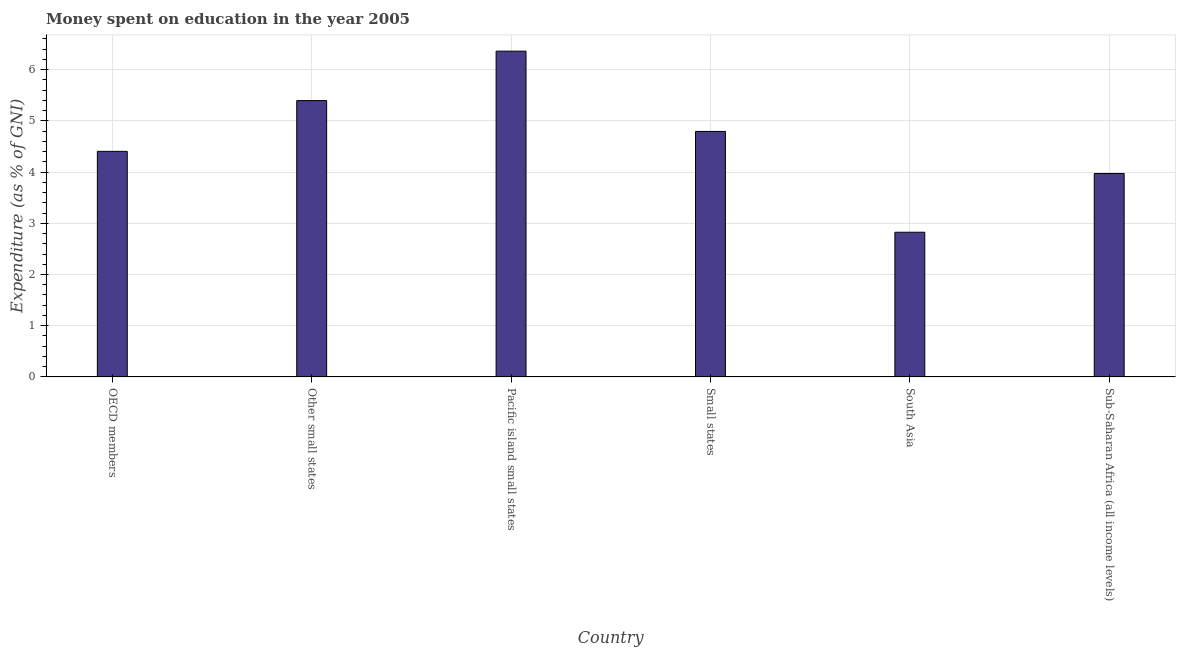What is the title of the graph?
Provide a succinct answer. Money spent on education in the year 2005. What is the label or title of the X-axis?
Your response must be concise. Country. What is the label or title of the Y-axis?
Your response must be concise. Expenditure (as % of GNI). What is the expenditure on education in OECD members?
Make the answer very short. 4.41. Across all countries, what is the maximum expenditure on education?
Your answer should be very brief. 6.36. Across all countries, what is the minimum expenditure on education?
Provide a short and direct response. 2.83. In which country was the expenditure on education maximum?
Your answer should be compact. Pacific island small states. In which country was the expenditure on education minimum?
Give a very brief answer. South Asia. What is the sum of the expenditure on education?
Your answer should be compact. 27.76. What is the difference between the expenditure on education in OECD members and Sub-Saharan Africa (all income levels)?
Your response must be concise. 0.43. What is the average expenditure on education per country?
Provide a short and direct response. 4.63. What is the median expenditure on education?
Your answer should be very brief. 4.6. What is the ratio of the expenditure on education in OECD members to that in South Asia?
Offer a very short reply. 1.56. Is the expenditure on education in Pacific island small states less than that in Sub-Saharan Africa (all income levels)?
Provide a short and direct response. No. Is the difference between the expenditure on education in Pacific island small states and Small states greater than the difference between any two countries?
Make the answer very short. No. What is the difference between the highest and the second highest expenditure on education?
Ensure brevity in your answer.  0.96. Is the sum of the expenditure on education in OECD members and Pacific island small states greater than the maximum expenditure on education across all countries?
Ensure brevity in your answer.  Yes. What is the difference between the highest and the lowest expenditure on education?
Provide a succinct answer. 3.54. In how many countries, is the expenditure on education greater than the average expenditure on education taken over all countries?
Make the answer very short. 3. How many bars are there?
Offer a very short reply. 6. Are all the bars in the graph horizontal?
Offer a terse response. No. What is the difference between two consecutive major ticks on the Y-axis?
Your answer should be compact. 1. Are the values on the major ticks of Y-axis written in scientific E-notation?
Keep it short and to the point. No. What is the Expenditure (as % of GNI) of OECD members?
Your answer should be compact. 4.41. What is the Expenditure (as % of GNI) in Other small states?
Offer a terse response. 5.4. What is the Expenditure (as % of GNI) of Pacific island small states?
Offer a very short reply. 6.36. What is the Expenditure (as % of GNI) in Small states?
Provide a short and direct response. 4.79. What is the Expenditure (as % of GNI) of South Asia?
Your response must be concise. 2.83. What is the Expenditure (as % of GNI) of Sub-Saharan Africa (all income levels)?
Offer a terse response. 3.97. What is the difference between the Expenditure (as % of GNI) in OECD members and Other small states?
Make the answer very short. -0.99. What is the difference between the Expenditure (as % of GNI) in OECD members and Pacific island small states?
Provide a succinct answer. -1.96. What is the difference between the Expenditure (as % of GNI) in OECD members and Small states?
Offer a terse response. -0.39. What is the difference between the Expenditure (as % of GNI) in OECD members and South Asia?
Provide a succinct answer. 1.58. What is the difference between the Expenditure (as % of GNI) in OECD members and Sub-Saharan Africa (all income levels)?
Offer a very short reply. 0.43. What is the difference between the Expenditure (as % of GNI) in Other small states and Pacific island small states?
Your response must be concise. -0.97. What is the difference between the Expenditure (as % of GNI) in Other small states and Small states?
Your answer should be compact. 0.6. What is the difference between the Expenditure (as % of GNI) in Other small states and South Asia?
Provide a succinct answer. 2.57. What is the difference between the Expenditure (as % of GNI) in Other small states and Sub-Saharan Africa (all income levels)?
Your response must be concise. 1.42. What is the difference between the Expenditure (as % of GNI) in Pacific island small states and Small states?
Offer a very short reply. 1.57. What is the difference between the Expenditure (as % of GNI) in Pacific island small states and South Asia?
Provide a short and direct response. 3.54. What is the difference between the Expenditure (as % of GNI) in Pacific island small states and Sub-Saharan Africa (all income levels)?
Provide a succinct answer. 2.39. What is the difference between the Expenditure (as % of GNI) in Small states and South Asia?
Your answer should be very brief. 1.97. What is the difference between the Expenditure (as % of GNI) in Small states and Sub-Saharan Africa (all income levels)?
Offer a very short reply. 0.82. What is the difference between the Expenditure (as % of GNI) in South Asia and Sub-Saharan Africa (all income levels)?
Make the answer very short. -1.15. What is the ratio of the Expenditure (as % of GNI) in OECD members to that in Other small states?
Your answer should be very brief. 0.82. What is the ratio of the Expenditure (as % of GNI) in OECD members to that in Pacific island small states?
Ensure brevity in your answer.  0.69. What is the ratio of the Expenditure (as % of GNI) in OECD members to that in Small states?
Provide a short and direct response. 0.92. What is the ratio of the Expenditure (as % of GNI) in OECD members to that in South Asia?
Keep it short and to the point. 1.56. What is the ratio of the Expenditure (as % of GNI) in OECD members to that in Sub-Saharan Africa (all income levels)?
Ensure brevity in your answer.  1.11. What is the ratio of the Expenditure (as % of GNI) in Other small states to that in Pacific island small states?
Keep it short and to the point. 0.85. What is the ratio of the Expenditure (as % of GNI) in Other small states to that in Small states?
Offer a terse response. 1.13. What is the ratio of the Expenditure (as % of GNI) in Other small states to that in South Asia?
Offer a terse response. 1.91. What is the ratio of the Expenditure (as % of GNI) in Other small states to that in Sub-Saharan Africa (all income levels)?
Offer a very short reply. 1.36. What is the ratio of the Expenditure (as % of GNI) in Pacific island small states to that in Small states?
Provide a short and direct response. 1.33. What is the ratio of the Expenditure (as % of GNI) in Pacific island small states to that in South Asia?
Your response must be concise. 2.25. What is the ratio of the Expenditure (as % of GNI) in Pacific island small states to that in Sub-Saharan Africa (all income levels)?
Ensure brevity in your answer.  1.6. What is the ratio of the Expenditure (as % of GNI) in Small states to that in South Asia?
Offer a terse response. 1.7. What is the ratio of the Expenditure (as % of GNI) in Small states to that in Sub-Saharan Africa (all income levels)?
Keep it short and to the point. 1.21. What is the ratio of the Expenditure (as % of GNI) in South Asia to that in Sub-Saharan Africa (all income levels)?
Your answer should be compact. 0.71. 